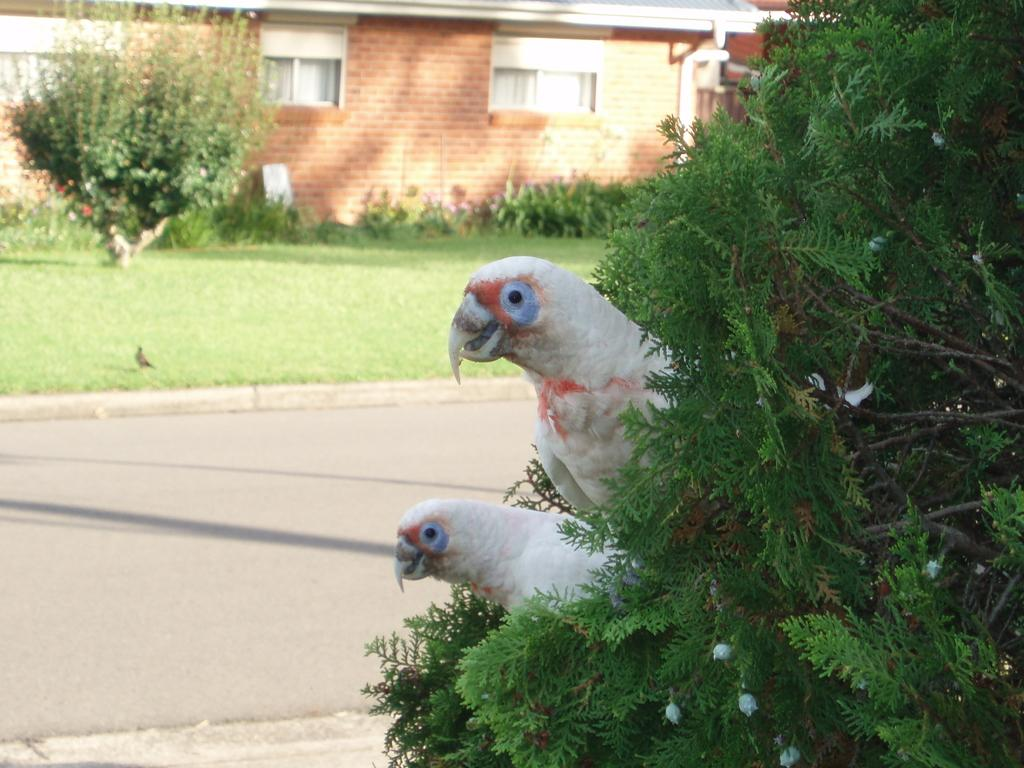How many birds are in the image? There are two birds in the image. What else can be seen in the image besides the birds? There is a plant, a building in the background, grass, and a group of trees in the background. What is the building in the background made of? The building has windows, which suggests it is made of a material that can support window installation. What type of vegetation is present in the background of the image? There is grass and a group of trees in the background of the image. What type of cub is celebrating its birthday in the image? There is no cub or birthday celebration present in the image. What type of lumber is being used to construct the building in the image? The image does not provide enough information to determine the type of lumber used in the construction of the building. 